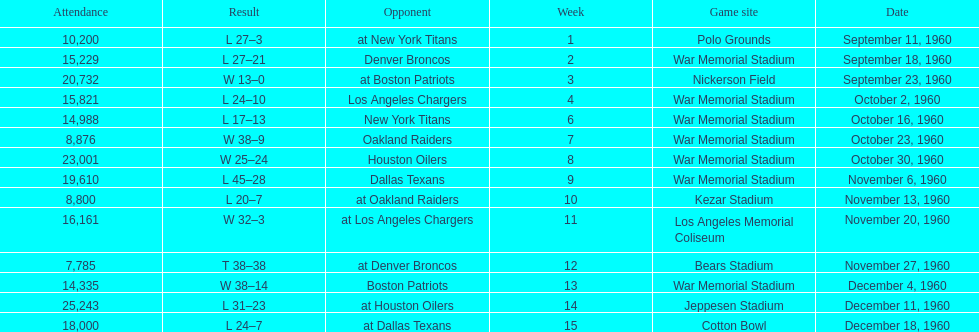How many games had an attendance of 10,000 at most? 11. 